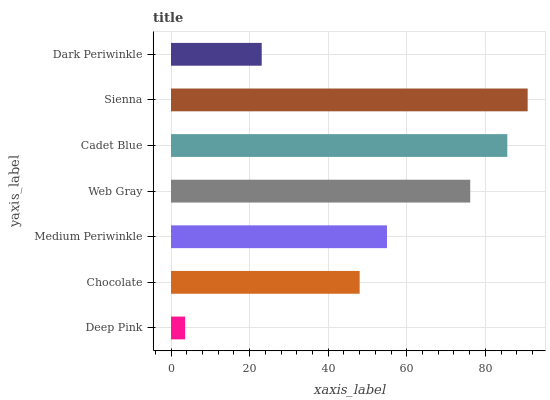Is Deep Pink the minimum?
Answer yes or no. Yes. Is Sienna the maximum?
Answer yes or no. Yes. Is Chocolate the minimum?
Answer yes or no. No. Is Chocolate the maximum?
Answer yes or no. No. Is Chocolate greater than Deep Pink?
Answer yes or no. Yes. Is Deep Pink less than Chocolate?
Answer yes or no. Yes. Is Deep Pink greater than Chocolate?
Answer yes or no. No. Is Chocolate less than Deep Pink?
Answer yes or no. No. Is Medium Periwinkle the high median?
Answer yes or no. Yes. Is Medium Periwinkle the low median?
Answer yes or no. Yes. Is Cadet Blue the high median?
Answer yes or no. No. Is Sienna the low median?
Answer yes or no. No. 